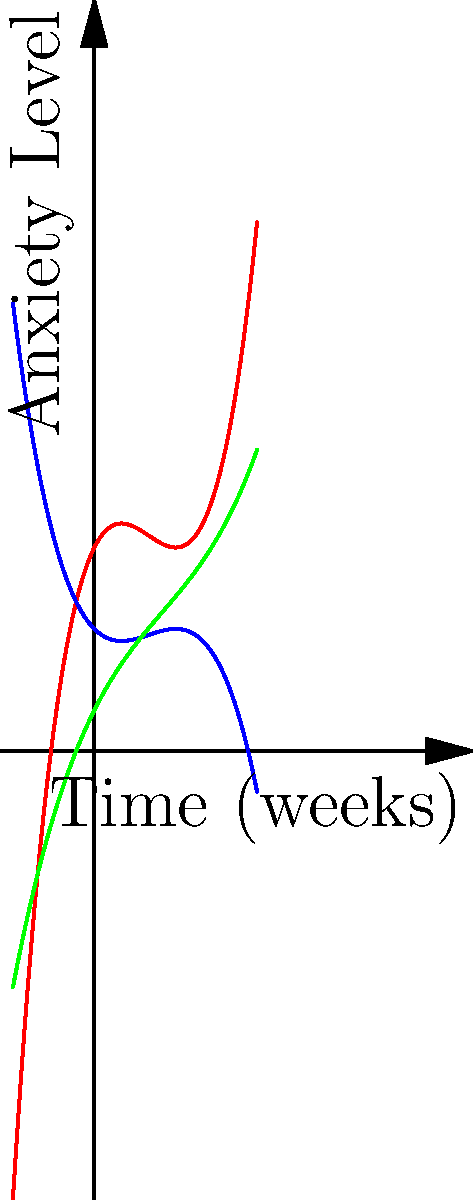The graph shows the anxiety levels of three clients over time as they implement different anxiety management techniques. Which technique appears to be most effective in reducing anxiety levels over the long term (towards the end of the 4-week period), and what does this suggest about the nature of anxiety management? To determine the most effective technique for reducing anxiety levels over the long term, we need to analyze the behavior of each curve towards the end of the 4-week period:

1. Technique A (red curve): This curve shows a sharp increase in anxiety levels towards the end of the period. The function is $f(x) = 0.5x^3 - 2x^2 + 2x + 5$, which has a positive leading coefficient, indicating rapid growth as x increases.

2. Technique B (blue curve): This curve shows a gradual decrease in anxiety levels over time. The function is $f(x) = -0.25x^3 + x^2 - x + 3$, which has a negative leading coefficient, indicating an overall downward trend as x increases.

3. Technique C (green curve): This curve shows a moderate increase in anxiety levels towards the end of the period. The function is $f(x) = 0.1x^3 - 0.5x^2 + 2x + 1$, which has a positive leading coefficient, but the increase is less dramatic than Technique A.

Comparing these three techniques, Technique B appears to be the most effective in reducing anxiety levels over the long term. It shows a consistent downward trend, unlike the other two techniques which show increases in anxiety levels towards the end of the period.

This suggests that effective anxiety management often requires consistent, gradual improvement rather than quick fixes. Technique B, which shows steady progress, may represent a more sustainable approach to managing anxiety, such as cognitive-behavioral therapy or mindfulness practices that build coping skills over time.

The other techniques, while potentially showing initial improvements, may represent less sustainable methods that don't address the root causes of anxiety or don't provide long-term coping strategies.
Answer: Technique B, suggesting gradual, consistent improvement is most effective for long-term anxiety management. 